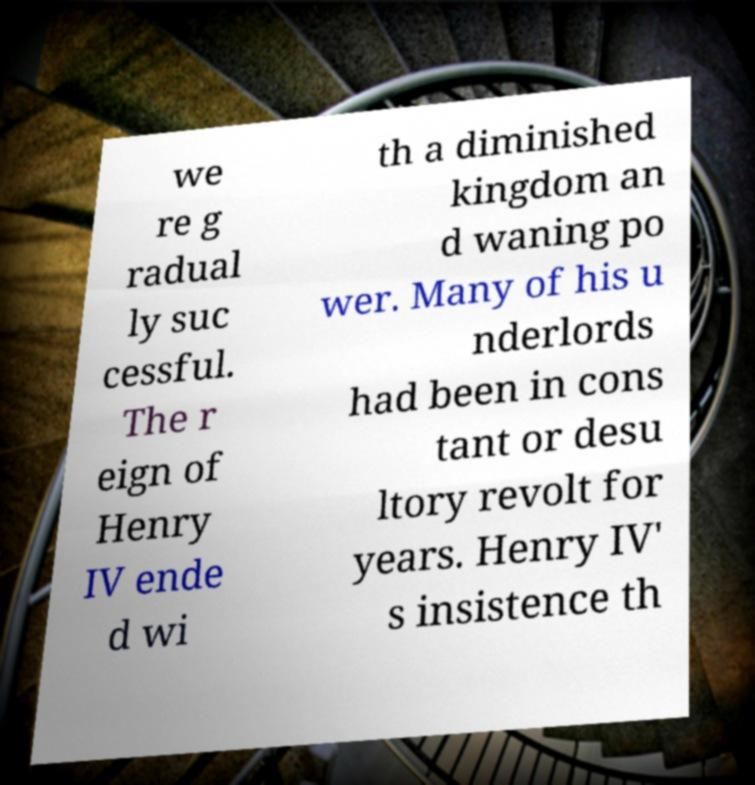What messages or text are displayed in this image? I need them in a readable, typed format. we re g radual ly suc cessful. The r eign of Henry IV ende d wi th a diminished kingdom an d waning po wer. Many of his u nderlords had been in cons tant or desu ltory revolt for years. Henry IV' s insistence th 